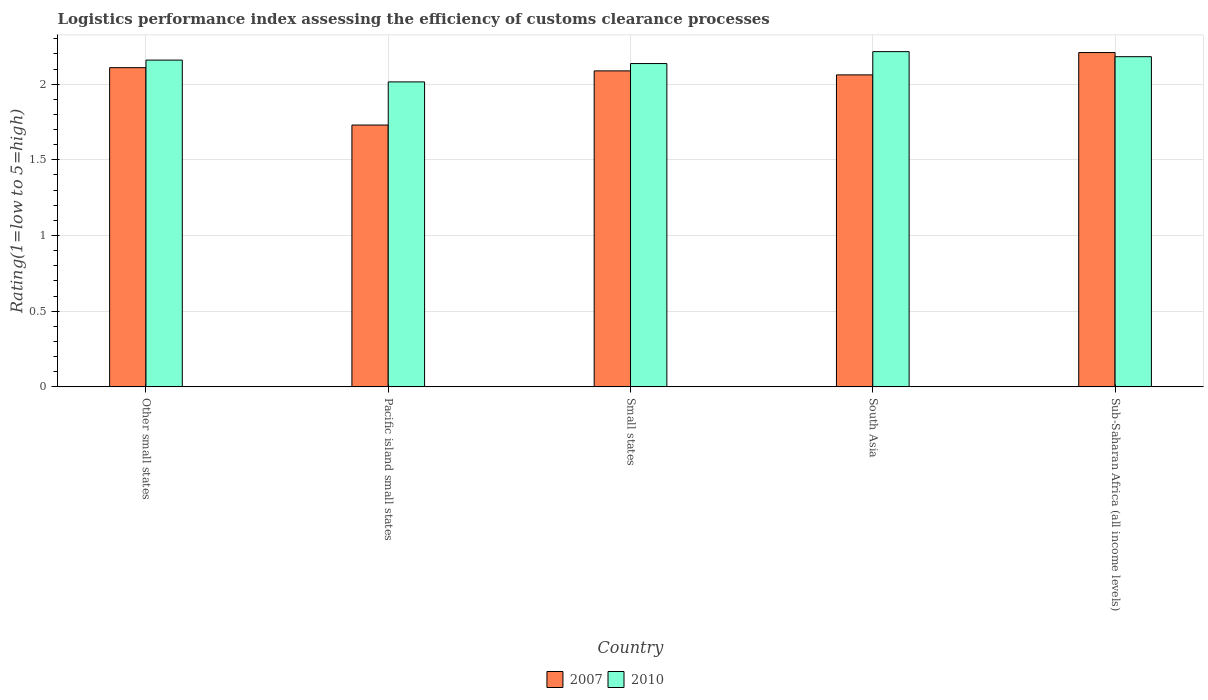How many different coloured bars are there?
Make the answer very short. 2. How many groups of bars are there?
Provide a short and direct response. 5. Are the number of bars per tick equal to the number of legend labels?
Give a very brief answer. Yes. What is the label of the 3rd group of bars from the left?
Ensure brevity in your answer.  Small states. What is the Logistic performance index in 2010 in Pacific island small states?
Your answer should be compact. 2.02. Across all countries, what is the maximum Logistic performance index in 2010?
Provide a succinct answer. 2.21. Across all countries, what is the minimum Logistic performance index in 2010?
Provide a succinct answer. 2.02. In which country was the Logistic performance index in 2007 maximum?
Offer a very short reply. Sub-Saharan Africa (all income levels). In which country was the Logistic performance index in 2007 minimum?
Offer a very short reply. Pacific island small states. What is the total Logistic performance index in 2007 in the graph?
Give a very brief answer. 10.2. What is the difference between the Logistic performance index in 2007 in Small states and that in Sub-Saharan Africa (all income levels)?
Keep it short and to the point. -0.12. What is the difference between the Logistic performance index in 2010 in Pacific island small states and the Logistic performance index in 2007 in Small states?
Offer a terse response. -0.07. What is the average Logistic performance index in 2010 per country?
Give a very brief answer. 2.14. What is the difference between the Logistic performance index of/in 2007 and Logistic performance index of/in 2010 in Pacific island small states?
Offer a terse response. -0.29. What is the ratio of the Logistic performance index in 2010 in Pacific island small states to that in South Asia?
Offer a very short reply. 0.91. What is the difference between the highest and the second highest Logistic performance index in 2010?
Your response must be concise. -0.06. What is the difference between the highest and the lowest Logistic performance index in 2007?
Keep it short and to the point. 0.48. Is the sum of the Logistic performance index in 2010 in Other small states and South Asia greater than the maximum Logistic performance index in 2007 across all countries?
Your response must be concise. Yes. What does the 1st bar from the left in Sub-Saharan Africa (all income levels) represents?
Provide a succinct answer. 2007. What does the 2nd bar from the right in Other small states represents?
Make the answer very short. 2007. How many bars are there?
Your answer should be very brief. 10. What is the difference between two consecutive major ticks on the Y-axis?
Offer a very short reply. 0.5. Where does the legend appear in the graph?
Offer a very short reply. Bottom center. How are the legend labels stacked?
Give a very brief answer. Horizontal. What is the title of the graph?
Provide a succinct answer. Logistics performance index assessing the efficiency of customs clearance processes. Does "1961" appear as one of the legend labels in the graph?
Your response must be concise. No. What is the label or title of the Y-axis?
Your answer should be very brief. Rating(1=low to 5=high). What is the Rating(1=low to 5=high) in 2007 in Other small states?
Your answer should be very brief. 2.11. What is the Rating(1=low to 5=high) in 2010 in Other small states?
Your response must be concise. 2.16. What is the Rating(1=low to 5=high) in 2007 in Pacific island small states?
Give a very brief answer. 1.73. What is the Rating(1=low to 5=high) in 2010 in Pacific island small states?
Provide a short and direct response. 2.02. What is the Rating(1=low to 5=high) in 2007 in Small states?
Provide a succinct answer. 2.09. What is the Rating(1=low to 5=high) in 2010 in Small states?
Offer a terse response. 2.14. What is the Rating(1=low to 5=high) of 2007 in South Asia?
Ensure brevity in your answer.  2.06. What is the Rating(1=low to 5=high) of 2010 in South Asia?
Keep it short and to the point. 2.21. What is the Rating(1=low to 5=high) of 2007 in Sub-Saharan Africa (all income levels)?
Provide a short and direct response. 2.21. What is the Rating(1=low to 5=high) in 2010 in Sub-Saharan Africa (all income levels)?
Keep it short and to the point. 2.18. Across all countries, what is the maximum Rating(1=low to 5=high) of 2007?
Offer a very short reply. 2.21. Across all countries, what is the maximum Rating(1=low to 5=high) of 2010?
Keep it short and to the point. 2.21. Across all countries, what is the minimum Rating(1=low to 5=high) of 2007?
Offer a terse response. 1.73. Across all countries, what is the minimum Rating(1=low to 5=high) in 2010?
Your answer should be very brief. 2.02. What is the total Rating(1=low to 5=high) of 2007 in the graph?
Keep it short and to the point. 10.2. What is the total Rating(1=low to 5=high) of 2010 in the graph?
Provide a succinct answer. 10.71. What is the difference between the Rating(1=low to 5=high) in 2007 in Other small states and that in Pacific island small states?
Your answer should be very brief. 0.38. What is the difference between the Rating(1=low to 5=high) in 2010 in Other small states and that in Pacific island small states?
Provide a succinct answer. 0.14. What is the difference between the Rating(1=low to 5=high) of 2007 in Other small states and that in Small states?
Keep it short and to the point. 0.02. What is the difference between the Rating(1=low to 5=high) in 2010 in Other small states and that in Small states?
Offer a terse response. 0.02. What is the difference between the Rating(1=low to 5=high) of 2007 in Other small states and that in South Asia?
Offer a very short reply. 0.05. What is the difference between the Rating(1=low to 5=high) in 2010 in Other small states and that in South Asia?
Your response must be concise. -0.06. What is the difference between the Rating(1=low to 5=high) in 2007 in Other small states and that in Sub-Saharan Africa (all income levels)?
Your response must be concise. -0.1. What is the difference between the Rating(1=low to 5=high) in 2010 in Other small states and that in Sub-Saharan Africa (all income levels)?
Your response must be concise. -0.02. What is the difference between the Rating(1=low to 5=high) in 2007 in Pacific island small states and that in Small states?
Keep it short and to the point. -0.36. What is the difference between the Rating(1=low to 5=high) of 2010 in Pacific island small states and that in Small states?
Provide a short and direct response. -0.12. What is the difference between the Rating(1=low to 5=high) in 2007 in Pacific island small states and that in South Asia?
Ensure brevity in your answer.  -0.33. What is the difference between the Rating(1=low to 5=high) in 2010 in Pacific island small states and that in South Asia?
Give a very brief answer. -0.2. What is the difference between the Rating(1=low to 5=high) in 2007 in Pacific island small states and that in Sub-Saharan Africa (all income levels)?
Your answer should be very brief. -0.48. What is the difference between the Rating(1=low to 5=high) of 2007 in Small states and that in South Asia?
Your response must be concise. 0.03. What is the difference between the Rating(1=low to 5=high) in 2010 in Small states and that in South Asia?
Your answer should be very brief. -0.08. What is the difference between the Rating(1=low to 5=high) in 2007 in Small states and that in Sub-Saharan Africa (all income levels)?
Offer a very short reply. -0.12. What is the difference between the Rating(1=low to 5=high) in 2010 in Small states and that in Sub-Saharan Africa (all income levels)?
Keep it short and to the point. -0.05. What is the difference between the Rating(1=low to 5=high) of 2007 in South Asia and that in Sub-Saharan Africa (all income levels)?
Your response must be concise. -0.15. What is the difference between the Rating(1=low to 5=high) in 2010 in South Asia and that in Sub-Saharan Africa (all income levels)?
Ensure brevity in your answer.  0.03. What is the difference between the Rating(1=low to 5=high) of 2007 in Other small states and the Rating(1=low to 5=high) of 2010 in Pacific island small states?
Ensure brevity in your answer.  0.09. What is the difference between the Rating(1=low to 5=high) of 2007 in Other small states and the Rating(1=low to 5=high) of 2010 in Small states?
Offer a very short reply. -0.03. What is the difference between the Rating(1=low to 5=high) of 2007 in Other small states and the Rating(1=low to 5=high) of 2010 in South Asia?
Provide a succinct answer. -0.11. What is the difference between the Rating(1=low to 5=high) of 2007 in Other small states and the Rating(1=low to 5=high) of 2010 in Sub-Saharan Africa (all income levels)?
Make the answer very short. -0.07. What is the difference between the Rating(1=low to 5=high) of 2007 in Pacific island small states and the Rating(1=low to 5=high) of 2010 in Small states?
Keep it short and to the point. -0.41. What is the difference between the Rating(1=low to 5=high) of 2007 in Pacific island small states and the Rating(1=low to 5=high) of 2010 in South Asia?
Offer a very short reply. -0.48. What is the difference between the Rating(1=low to 5=high) in 2007 in Pacific island small states and the Rating(1=low to 5=high) in 2010 in Sub-Saharan Africa (all income levels)?
Your answer should be compact. -0.45. What is the difference between the Rating(1=low to 5=high) in 2007 in Small states and the Rating(1=low to 5=high) in 2010 in South Asia?
Your response must be concise. -0.13. What is the difference between the Rating(1=low to 5=high) in 2007 in Small states and the Rating(1=low to 5=high) in 2010 in Sub-Saharan Africa (all income levels)?
Give a very brief answer. -0.09. What is the difference between the Rating(1=low to 5=high) in 2007 in South Asia and the Rating(1=low to 5=high) in 2010 in Sub-Saharan Africa (all income levels)?
Offer a very short reply. -0.12. What is the average Rating(1=low to 5=high) of 2007 per country?
Offer a terse response. 2.04. What is the average Rating(1=low to 5=high) of 2010 per country?
Offer a very short reply. 2.14. What is the difference between the Rating(1=low to 5=high) of 2007 and Rating(1=low to 5=high) of 2010 in Pacific island small states?
Provide a succinct answer. -0.28. What is the difference between the Rating(1=low to 5=high) of 2007 and Rating(1=low to 5=high) of 2010 in Small states?
Ensure brevity in your answer.  -0.05. What is the difference between the Rating(1=low to 5=high) in 2007 and Rating(1=low to 5=high) in 2010 in South Asia?
Your response must be concise. -0.15. What is the difference between the Rating(1=low to 5=high) in 2007 and Rating(1=low to 5=high) in 2010 in Sub-Saharan Africa (all income levels)?
Provide a short and direct response. 0.03. What is the ratio of the Rating(1=low to 5=high) of 2007 in Other small states to that in Pacific island small states?
Provide a succinct answer. 1.22. What is the ratio of the Rating(1=low to 5=high) of 2010 in Other small states to that in Pacific island small states?
Offer a terse response. 1.07. What is the ratio of the Rating(1=low to 5=high) of 2007 in Other small states to that in Small states?
Give a very brief answer. 1.01. What is the ratio of the Rating(1=low to 5=high) of 2010 in Other small states to that in Small states?
Offer a terse response. 1.01. What is the ratio of the Rating(1=low to 5=high) of 2007 in Other small states to that in South Asia?
Your answer should be very brief. 1.02. What is the ratio of the Rating(1=low to 5=high) in 2010 in Other small states to that in South Asia?
Keep it short and to the point. 0.97. What is the ratio of the Rating(1=low to 5=high) of 2007 in Other small states to that in Sub-Saharan Africa (all income levels)?
Offer a terse response. 0.95. What is the ratio of the Rating(1=low to 5=high) of 2007 in Pacific island small states to that in Small states?
Offer a very short reply. 0.83. What is the ratio of the Rating(1=low to 5=high) of 2010 in Pacific island small states to that in Small states?
Provide a succinct answer. 0.94. What is the ratio of the Rating(1=low to 5=high) in 2007 in Pacific island small states to that in South Asia?
Provide a succinct answer. 0.84. What is the ratio of the Rating(1=low to 5=high) in 2010 in Pacific island small states to that in South Asia?
Your response must be concise. 0.91. What is the ratio of the Rating(1=low to 5=high) of 2007 in Pacific island small states to that in Sub-Saharan Africa (all income levels)?
Offer a terse response. 0.78. What is the ratio of the Rating(1=low to 5=high) in 2010 in Pacific island small states to that in Sub-Saharan Africa (all income levels)?
Offer a very short reply. 0.92. What is the ratio of the Rating(1=low to 5=high) of 2007 in Small states to that in South Asia?
Provide a succinct answer. 1.01. What is the ratio of the Rating(1=low to 5=high) in 2010 in Small states to that in South Asia?
Ensure brevity in your answer.  0.96. What is the ratio of the Rating(1=low to 5=high) of 2007 in Small states to that in Sub-Saharan Africa (all income levels)?
Make the answer very short. 0.95. What is the ratio of the Rating(1=low to 5=high) of 2010 in Small states to that in Sub-Saharan Africa (all income levels)?
Provide a succinct answer. 0.98. What is the ratio of the Rating(1=low to 5=high) in 2007 in South Asia to that in Sub-Saharan Africa (all income levels)?
Offer a terse response. 0.93. What is the ratio of the Rating(1=low to 5=high) in 2010 in South Asia to that in Sub-Saharan Africa (all income levels)?
Your answer should be very brief. 1.02. What is the difference between the highest and the second highest Rating(1=low to 5=high) of 2007?
Provide a short and direct response. 0.1. What is the difference between the highest and the lowest Rating(1=low to 5=high) of 2007?
Your answer should be very brief. 0.48. What is the difference between the highest and the lowest Rating(1=low to 5=high) in 2010?
Ensure brevity in your answer.  0.2. 